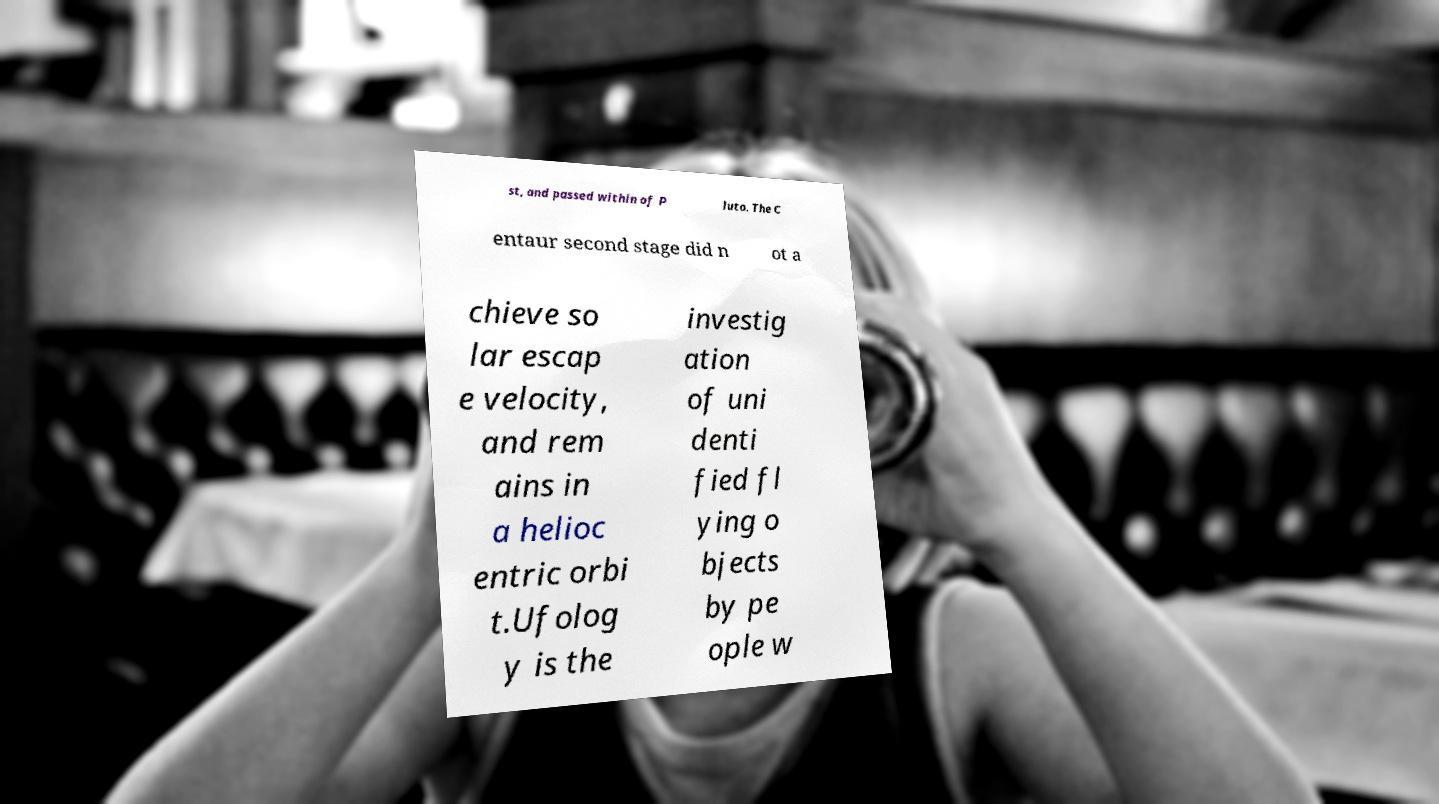Can you accurately transcribe the text from the provided image for me? st, and passed within of P luto. The C entaur second stage did n ot a chieve so lar escap e velocity, and rem ains in a helioc entric orbi t.Ufolog y is the investig ation of uni denti fied fl ying o bjects by pe ople w 